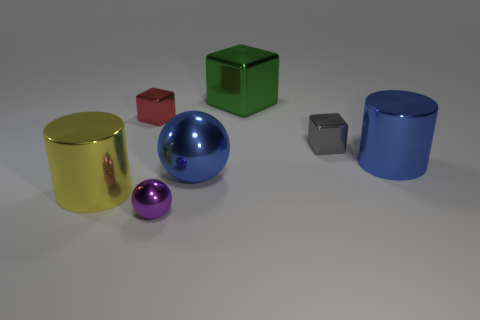Is there any other thing that has the same color as the large ball?
Provide a succinct answer. Yes. Is the green shiny cube the same size as the blue metallic cylinder?
Offer a terse response. Yes. How many metal cubes have the same size as the purple shiny object?
Provide a succinct answer. 2. What shape is the large object that is the same color as the big metal ball?
Your answer should be very brief. Cylinder. Do the cylinder to the right of the gray cube and the cylinder that is left of the small red metal cube have the same material?
Your answer should be very brief. Yes. What color is the large metal block?
Your answer should be very brief. Green. How many yellow objects have the same shape as the small red thing?
Your answer should be very brief. 0. What color is the sphere that is the same size as the green shiny thing?
Offer a terse response. Blue. Are any cyan rubber blocks visible?
Offer a terse response. No. The large object that is on the right side of the big green shiny thing has what shape?
Offer a terse response. Cylinder. 